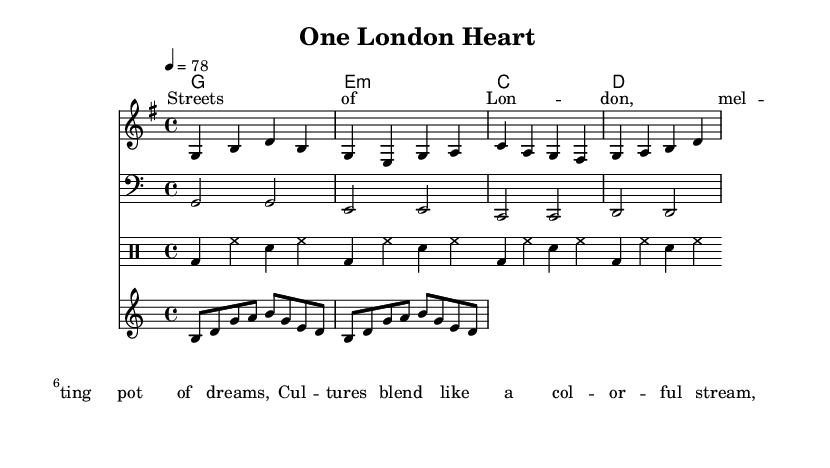What is the key signature of this music? The key signature is G major, which has one sharp (F#). This is indicated at the beginning of the score, where the key signature is shown.
Answer: G major What is the time signature of this piece? The time signature is 4/4, which appears at the start of the staff. It indicates that there are four beats in each measure and each quarter note gets one beat.
Answer: 4/4 What is the tempo of the song? The tempo is marked as 4 = 78, meaning there are 78 beats per minute with a quarter note receiving one beat. This indication is located at the top of the music score.
Answer: 78 How many measures are in the melody? The melody consists of four measures, which can be seen by counting the groups of notes separated by vertical lines (bar lines) in the melody staff.
Answer: 4 What style of chord progression is used in this reggae piece? The chord progression follows a common I-vi-IV-V pattern often used in reggae, which can be derived from analyzing the chords listed in the chord names under the melody. In this case, it includes G, E minor, C, and D.
Answer: I-vi-IV-V What rhythmic pattern do the drums follow in this piece? The drums mainly utilize a bass drum (bd) and snare (sn) pattern with hi-hat (hh) in between. This is typical of reggae and is evident in the drummode section, where the alternating bass and snare beats create a relaxed groove.
Answer: Bass-snare-hi-hat What theme is expressed in the lyrics of the song? The lyrics reflect cultural diversity and unity by describing London as a melting pot of cultures, emphasizing blending and harmony, which is a central theme in reggae music. The words “melting pot of dreams” highlight this idea.
Answer: Cultural diversity 